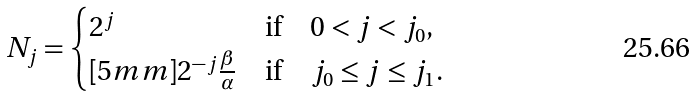Convert formula to latex. <formula><loc_0><loc_0><loc_500><loc_500>N _ { j } = \begin{cases} 2 ^ { j } & \text {if} \quad 0 < j < j _ { 0 } , \\ [ 5 m m ] 2 ^ { - j } \frac { \beta } { \alpha } & \text {if} \quad j _ { 0 } \leq j \leq j _ { 1 } . \end{cases}</formula> 